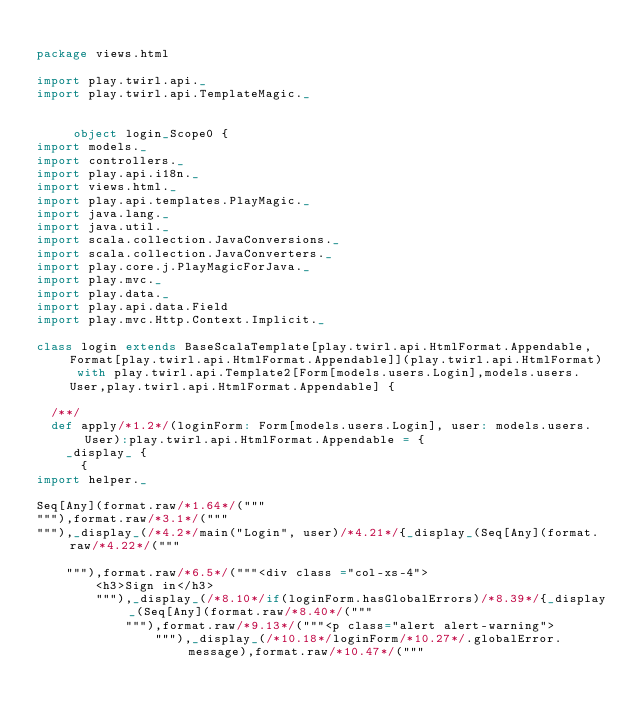Convert code to text. <code><loc_0><loc_0><loc_500><loc_500><_Scala_>
package views.html

import play.twirl.api._
import play.twirl.api.TemplateMagic._


     object login_Scope0 {
import models._
import controllers._
import play.api.i18n._
import views.html._
import play.api.templates.PlayMagic._
import java.lang._
import java.util._
import scala.collection.JavaConversions._
import scala.collection.JavaConverters._
import play.core.j.PlayMagicForJava._
import play.mvc._
import play.data._
import play.api.data.Field
import play.mvc.Http.Context.Implicit._

class login extends BaseScalaTemplate[play.twirl.api.HtmlFormat.Appendable,Format[play.twirl.api.HtmlFormat.Appendable]](play.twirl.api.HtmlFormat) with play.twirl.api.Template2[Form[models.users.Login],models.users.User,play.twirl.api.HtmlFormat.Appendable] {

  /**/
  def apply/*1.2*/(loginForm: Form[models.users.Login], user: models.users.User):play.twirl.api.HtmlFormat.Appendable = {
    _display_ {
      {
import helper._

Seq[Any](format.raw/*1.64*/("""
"""),format.raw/*3.1*/("""
"""),_display_(/*4.2*/main("Login", user)/*4.21*/{_display_(Seq[Any](format.raw/*4.22*/("""

    """),format.raw/*6.5*/("""<div class ="col-xs-4">
        <h3>Sign in</h3>
        """),_display_(/*8.10*/if(loginForm.hasGlobalErrors)/*8.39*/{_display_(Seq[Any](format.raw/*8.40*/("""
            """),format.raw/*9.13*/("""<p class="alert alert-warning">
                """),_display_(/*10.18*/loginForm/*10.27*/.globalError.message),format.raw/*10.47*/("""</code> 